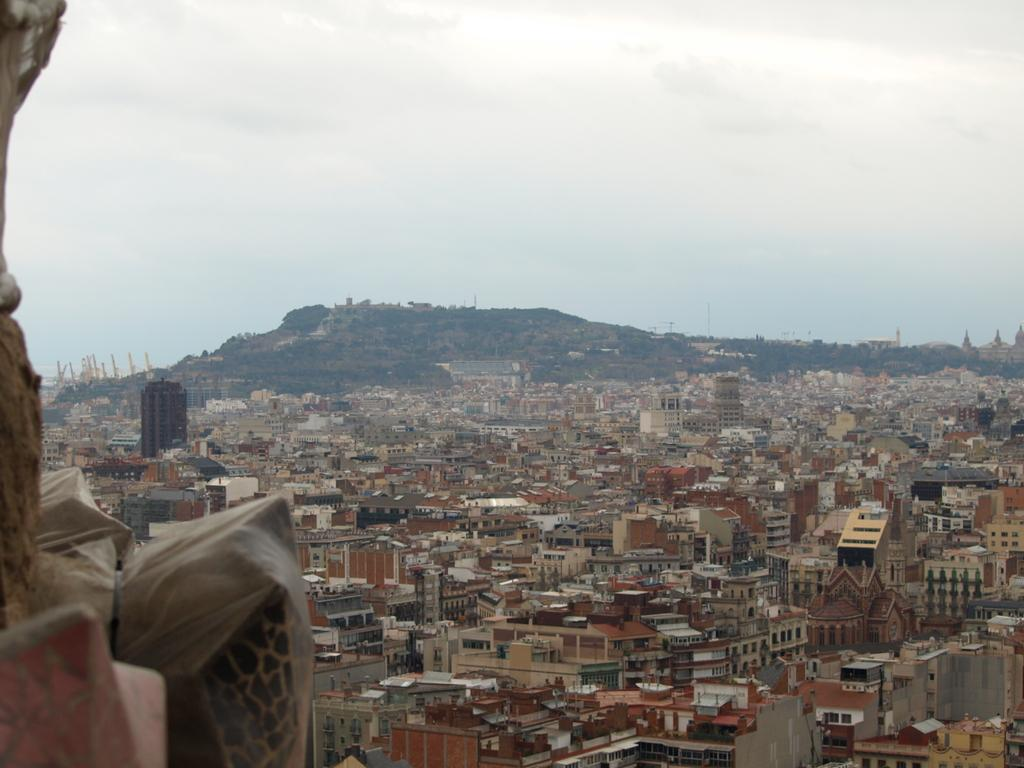What type of structures can be seen in the image? There are buildings in the image. What can be seen in the sky in the image? Clouds and the sky are visible at the top of the image. Can you describe the bottom left side of the image? There are unspecified elements on the bottom left side of the image. How many passengers are visible on the tongue in the image? There is no tongue or passengers present in the image. 